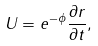<formula> <loc_0><loc_0><loc_500><loc_500>U = e ^ { - \phi } \frac { \partial r } { \partial t } ,</formula> 